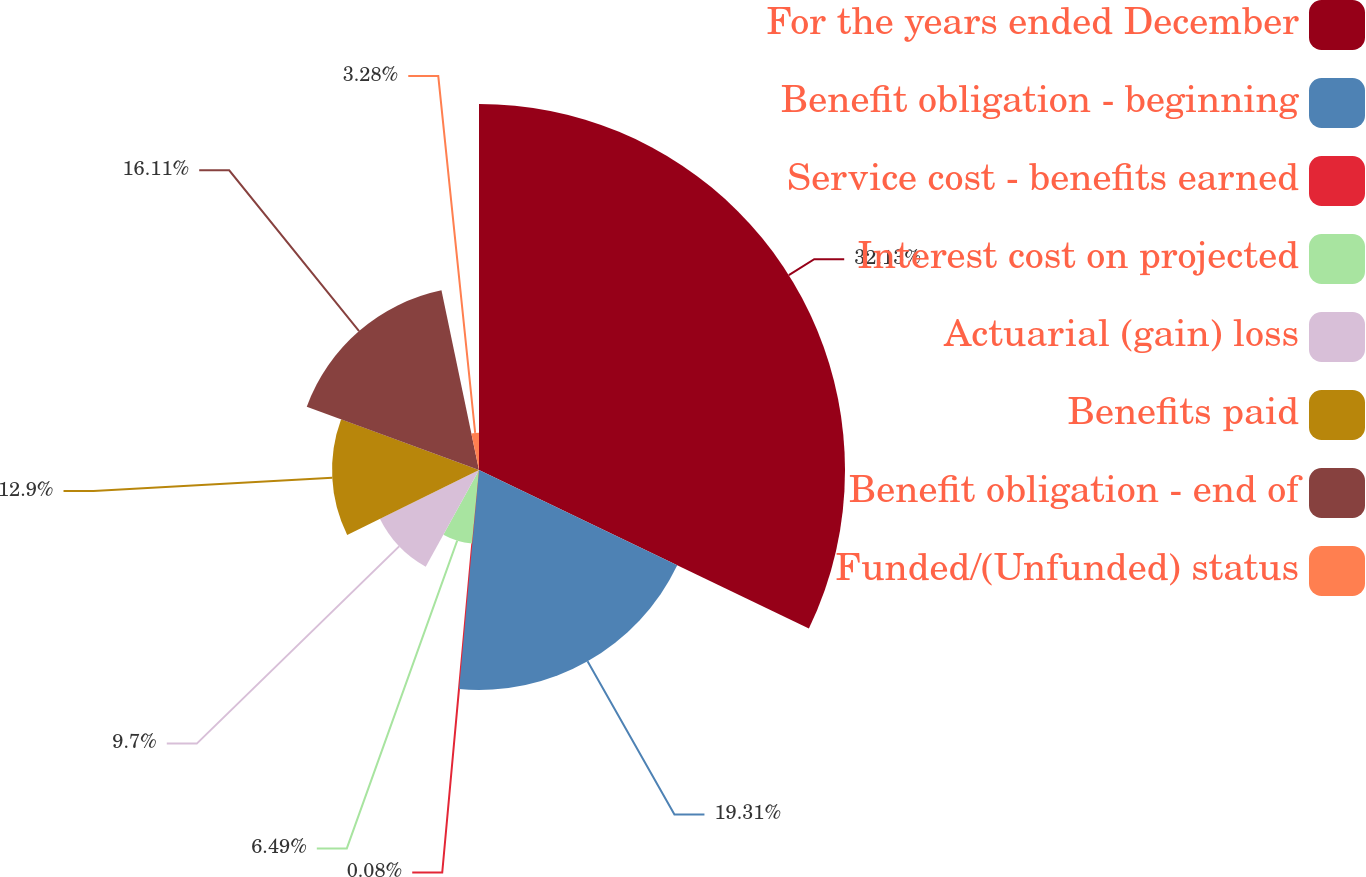Convert chart. <chart><loc_0><loc_0><loc_500><loc_500><pie_chart><fcel>For the years ended December<fcel>Benefit obligation - beginning<fcel>Service cost - benefits earned<fcel>Interest cost on projected<fcel>Actuarial (gain) loss<fcel>Benefits paid<fcel>Benefit obligation - end of<fcel>Funded/(Unfunded) status<nl><fcel>32.13%<fcel>19.31%<fcel>0.08%<fcel>6.49%<fcel>9.7%<fcel>12.9%<fcel>16.11%<fcel>3.28%<nl></chart> 